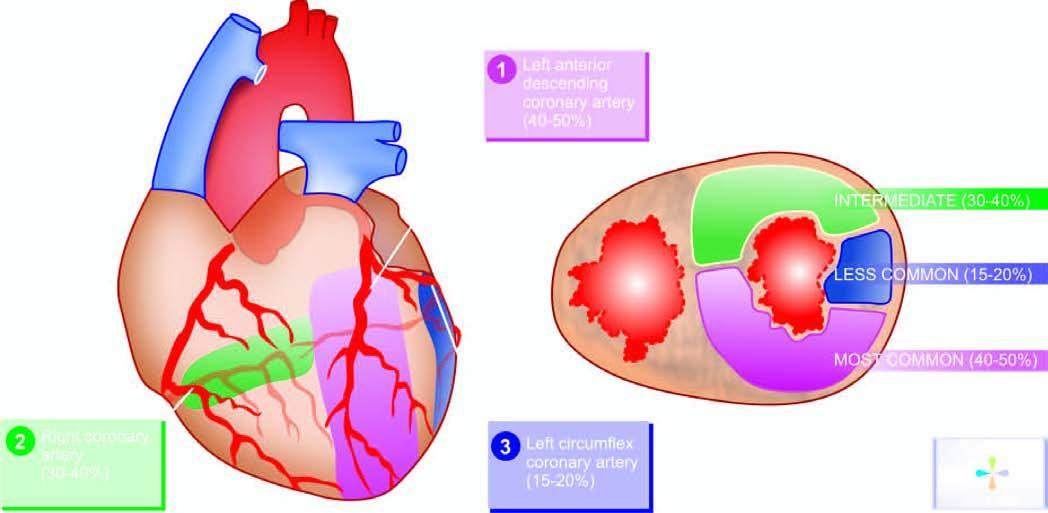does the figure show region of myocardium affected by stenosis of three respective coronary trunks in descending order shown as: 1 left anterior descending coronary, 2 right coronary and 3 left circumflex coronary artery in myocardial infarction?
Answer the question using a single word or phrase. Yes 